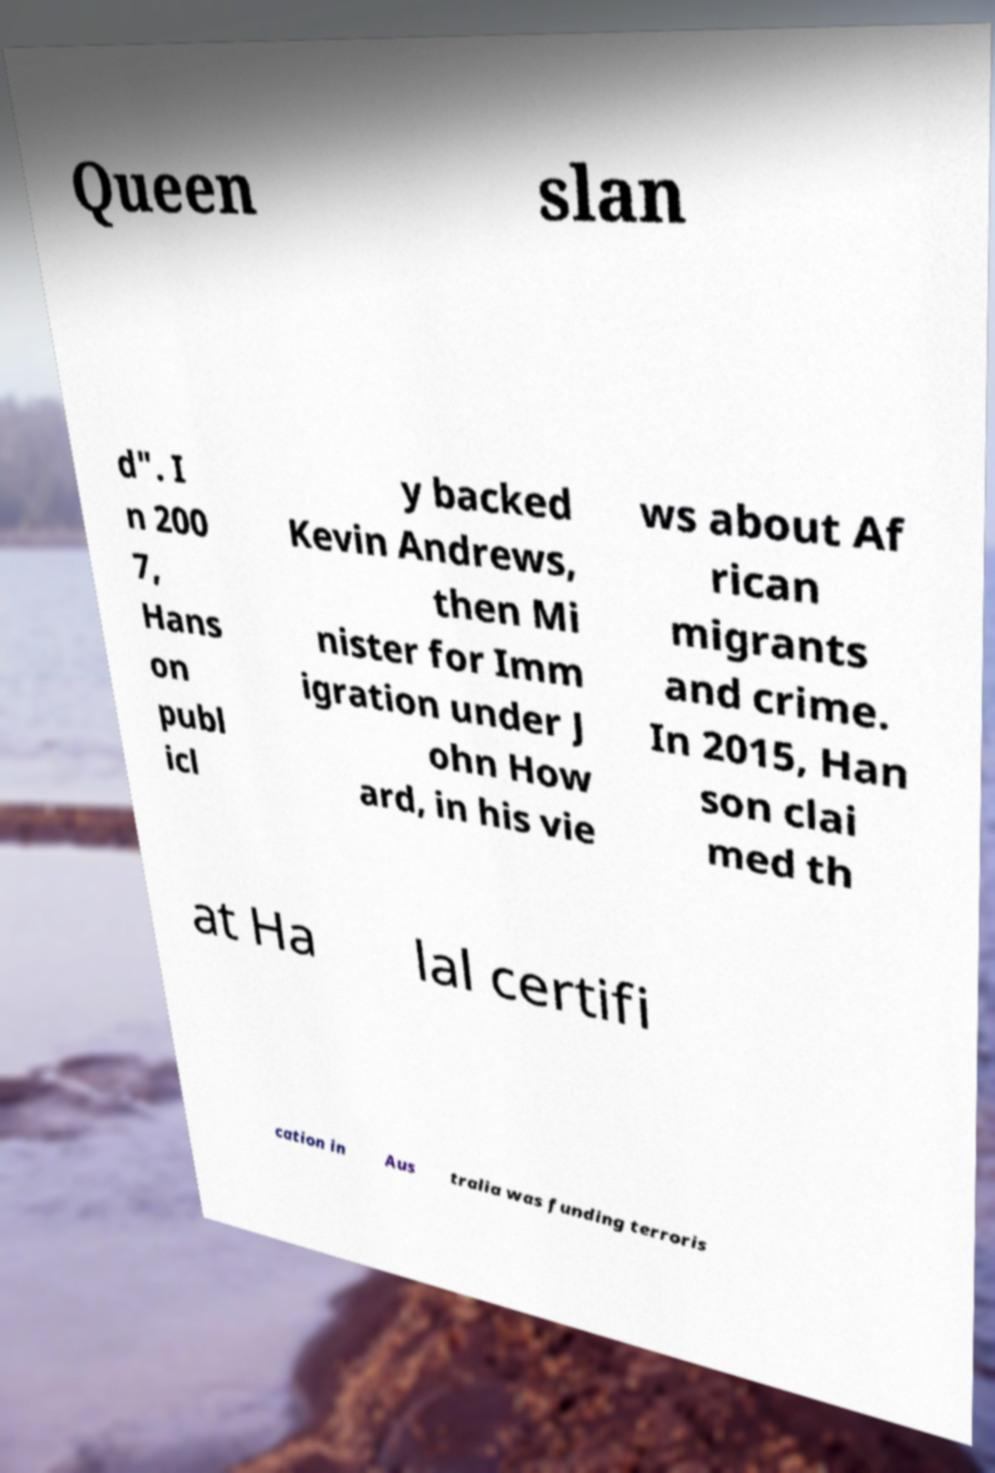Could you assist in decoding the text presented in this image and type it out clearly? Queen slan d". I n 200 7, Hans on publ icl y backed Kevin Andrews, then Mi nister for Imm igration under J ohn How ard, in his vie ws about Af rican migrants and crime. In 2015, Han son clai med th at Ha lal certifi cation in Aus tralia was funding terroris 